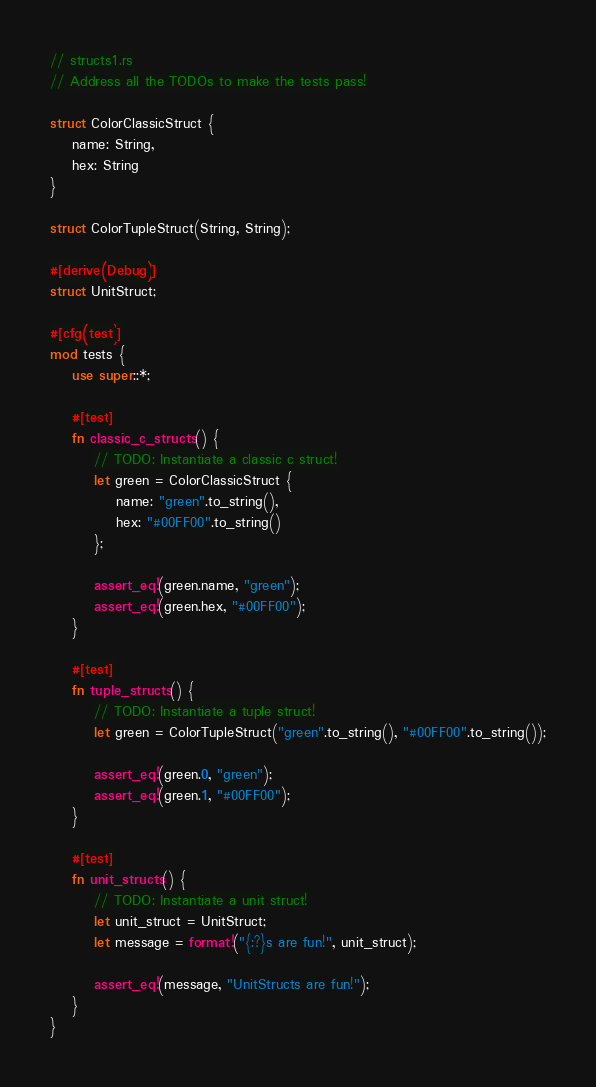<code> <loc_0><loc_0><loc_500><loc_500><_Rust_>// structs1.rs
// Address all the TODOs to make the tests pass!

struct ColorClassicStruct {
    name: String,
    hex: String
}

struct ColorTupleStruct(String, String);

#[derive(Debug)]
struct UnitStruct;

#[cfg(test)]
mod tests {
    use super::*;

    #[test]
    fn classic_c_structs() {
        // TODO: Instantiate a classic c struct!
        let green = ColorClassicStruct {
            name: "green".to_string(),
            hex: "#00FF00".to_string()
        };

        assert_eq!(green.name, "green");
        assert_eq!(green.hex, "#00FF00");
    }

    #[test]
    fn tuple_structs() {
        // TODO: Instantiate a tuple struct!
        let green = ColorTupleStruct("green".to_string(), "#00FF00".to_string());

        assert_eq!(green.0, "green");
        assert_eq!(green.1, "#00FF00");
    }

    #[test]
    fn unit_structs() {
        // TODO: Instantiate a unit struct!
        let unit_struct = UnitStruct;
        let message = format!("{:?}s are fun!", unit_struct);

        assert_eq!(message, "UnitStructs are fun!");
    }
}
</code> 